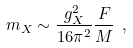Convert formula to latex. <formula><loc_0><loc_0><loc_500><loc_500>m _ { X } \sim \frac { g _ { X } ^ { 2 } } { 1 6 \pi ^ { 2 } } \frac { F } { M } \ ,</formula> 